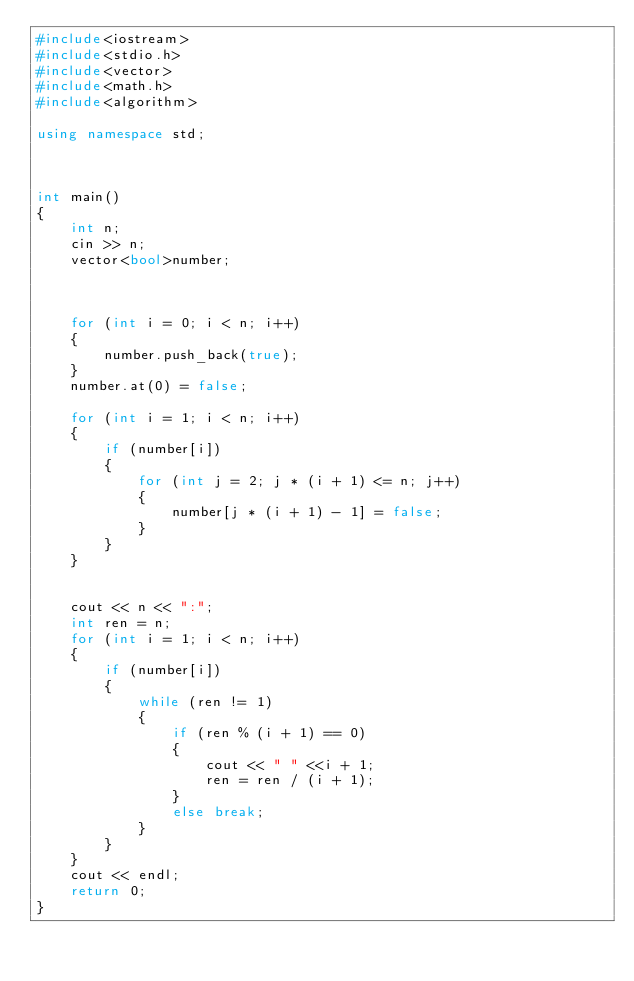Convert code to text. <code><loc_0><loc_0><loc_500><loc_500><_C++_>#include<iostream>
#include<stdio.h>
#include<vector>
#include<math.h>
#include<algorithm>

using namespace std;



int main()
{
	int n;
	cin >> n;
	vector<bool>number;



	for (int i = 0; i < n; i++)
	{
		number.push_back(true);
	}
	number.at(0) = false;

	for (int i = 1; i < n; i++)
	{
		if (number[i])
		{
			for (int j = 2; j * (i + 1) <= n; j++)
			{
				number[j * (i + 1) - 1] = false;
			}
		}
	}


	cout << n << ":";
	int ren = n;
	for (int i = 1; i < n; i++)
	{
		if (number[i])
		{
			while (ren != 1)
			{
				if (ren % (i + 1) == 0)
				{
					cout << " " <<i + 1;
					ren = ren / (i + 1);
				}
				else break;
			}
		}
	}
	cout << endl;
	return 0;
}</code> 